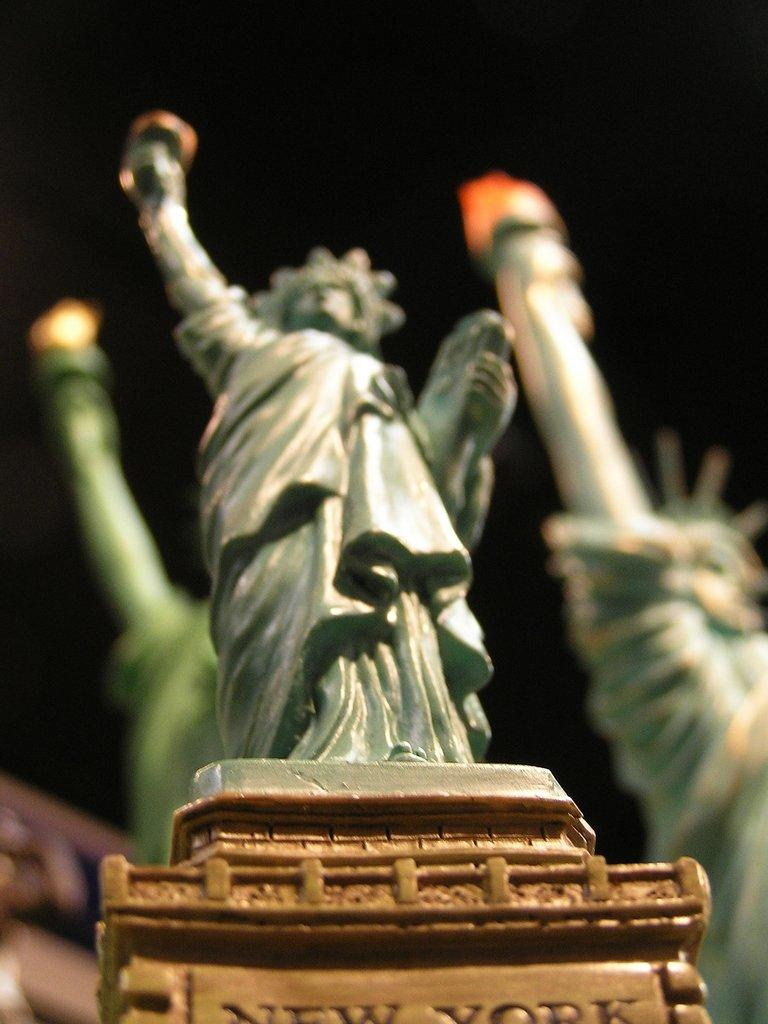What is the main subject of the image? There is a statue on a pedestal in the image. Are there any other statues visible in the image? Yes, there are two more statues behind the first statue. Can you describe the background of the image? The background of the image is blurred. What type of jar is being carried by the porter in the image? There is no porter or jar present in the image. How many oranges are on the ground near the statues in the image? There are no oranges present in the image. 